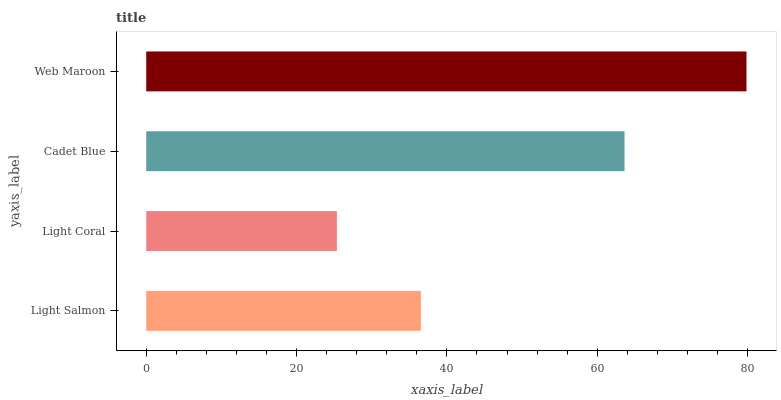Is Light Coral the minimum?
Answer yes or no. Yes. Is Web Maroon the maximum?
Answer yes or no. Yes. Is Cadet Blue the minimum?
Answer yes or no. No. Is Cadet Blue the maximum?
Answer yes or no. No. Is Cadet Blue greater than Light Coral?
Answer yes or no. Yes. Is Light Coral less than Cadet Blue?
Answer yes or no. Yes. Is Light Coral greater than Cadet Blue?
Answer yes or no. No. Is Cadet Blue less than Light Coral?
Answer yes or no. No. Is Cadet Blue the high median?
Answer yes or no. Yes. Is Light Salmon the low median?
Answer yes or no. Yes. Is Web Maroon the high median?
Answer yes or no. No. Is Cadet Blue the low median?
Answer yes or no. No. 